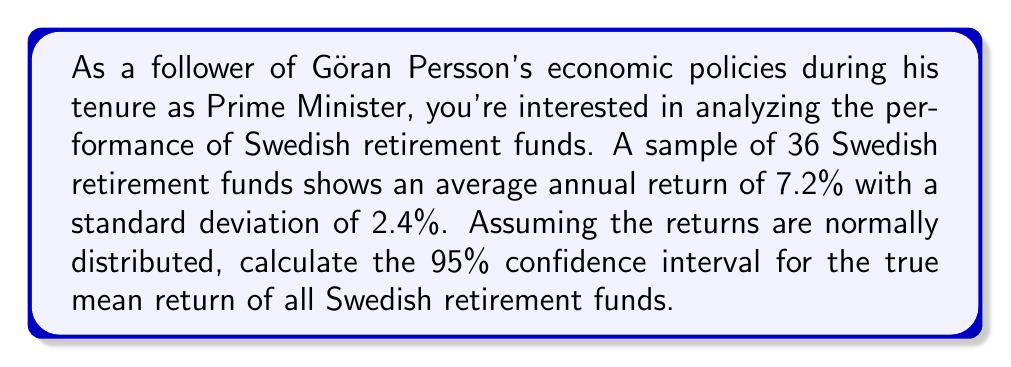Show me your answer to this math problem. Let's approach this step-by-step:

1) We're given:
   - Sample size (n) = 36
   - Sample mean ($\bar{x}$) = 7.2%
   - Sample standard deviation (s) = 2.4%
   - Confidence level = 95%

2) For a 95% confidence interval, we use a z-score of 1.96 (assuming a large sample size).

3) The formula for the confidence interval is:

   $$\bar{x} \pm z \cdot \frac{s}{\sqrt{n}}$$

4) Let's calculate the standard error:
   
   $$\frac{s}{\sqrt{n}} = \frac{2.4}{\sqrt{36}} = \frac{2.4}{6} = 0.4$$

5) Now, let's calculate the margin of error:
   
   $$1.96 \cdot 0.4 = 0.784$$

6) Therefore, the confidence interval is:

   $$7.2 \pm 0.784$$

7) This gives us:
   Lower bound: 7.2 - 0.784 = 6.416%
   Upper bound: 7.2 + 0.784 = 7.984%
Answer: (6.416%, 7.984%) 